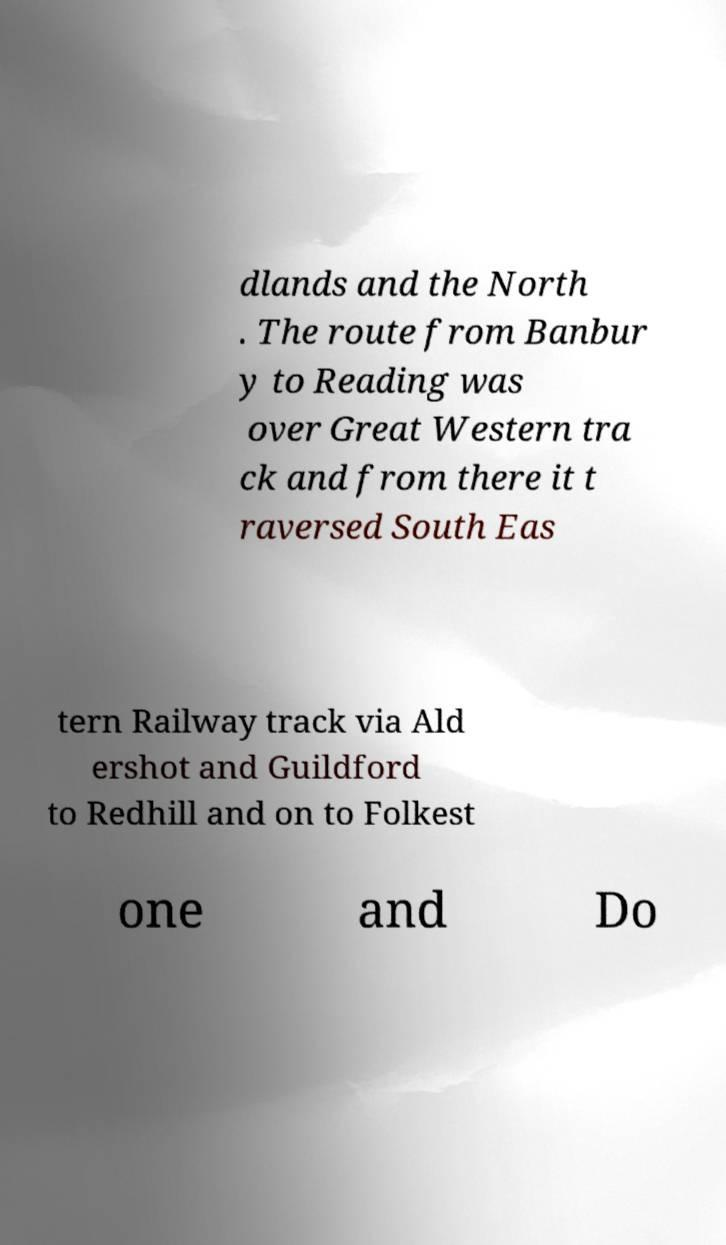There's text embedded in this image that I need extracted. Can you transcribe it verbatim? dlands and the North . The route from Banbur y to Reading was over Great Western tra ck and from there it t raversed South Eas tern Railway track via Ald ershot and Guildford to Redhill and on to Folkest one and Do 